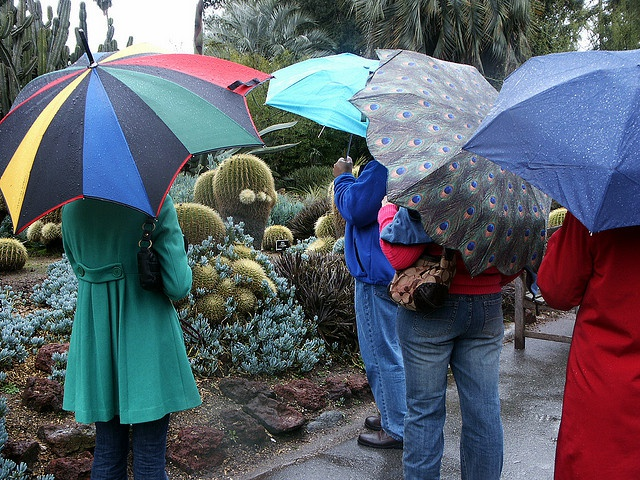Describe the objects in this image and their specific colors. I can see umbrella in black, gray, and lightblue tones, people in black and teal tones, umbrella in black, darkgray, gray, and lightgray tones, people in black, navy, darkblue, and gray tones, and umbrella in black, gray, lightblue, and navy tones in this image. 